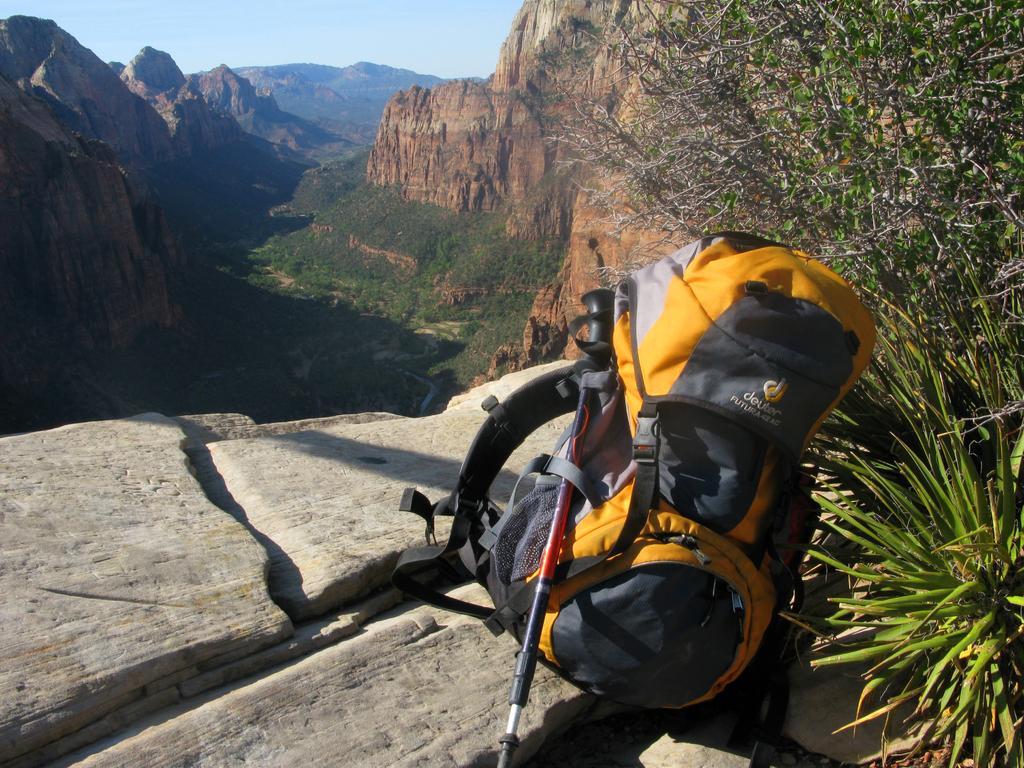Describe this image in one or two sentences. A backpack and a stick are placed on a stone beside a plant. There is deep valley in the background. 